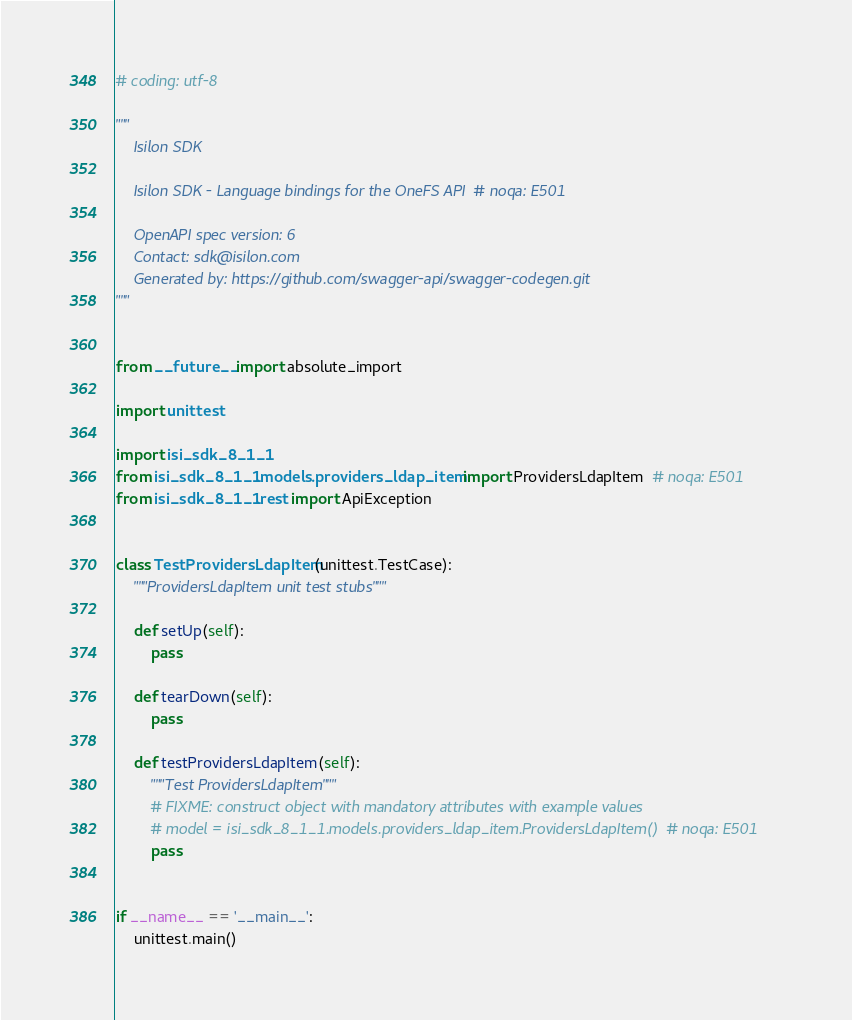<code> <loc_0><loc_0><loc_500><loc_500><_Python_># coding: utf-8

"""
    Isilon SDK

    Isilon SDK - Language bindings for the OneFS API  # noqa: E501

    OpenAPI spec version: 6
    Contact: sdk@isilon.com
    Generated by: https://github.com/swagger-api/swagger-codegen.git
"""


from __future__ import absolute_import

import unittest

import isi_sdk_8_1_1
from isi_sdk_8_1_1.models.providers_ldap_item import ProvidersLdapItem  # noqa: E501
from isi_sdk_8_1_1.rest import ApiException


class TestProvidersLdapItem(unittest.TestCase):
    """ProvidersLdapItem unit test stubs"""

    def setUp(self):
        pass

    def tearDown(self):
        pass

    def testProvidersLdapItem(self):
        """Test ProvidersLdapItem"""
        # FIXME: construct object with mandatory attributes with example values
        # model = isi_sdk_8_1_1.models.providers_ldap_item.ProvidersLdapItem()  # noqa: E501
        pass


if __name__ == '__main__':
    unittest.main()
</code> 